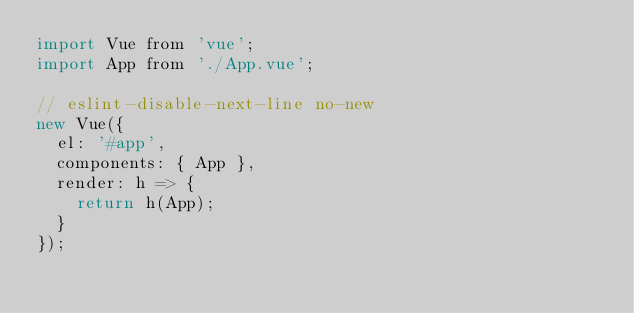<code> <loc_0><loc_0><loc_500><loc_500><_JavaScript_>import Vue from 'vue';
import App from './App.vue';

// eslint-disable-next-line no-new
new Vue({
  el: '#app',
  components: { App },
  render: h => {
    return h(App);
  }
});
</code> 